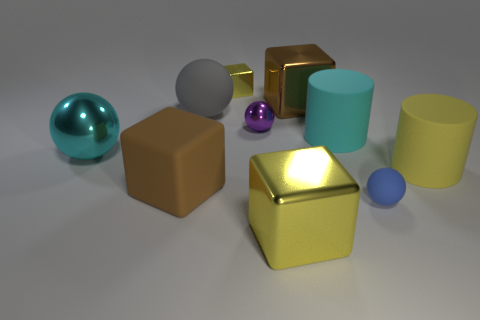Subtract all shiny blocks. How many blocks are left? 1 Subtract all red cylinders. How many yellow cubes are left? 2 Subtract all cyan balls. How many balls are left? 3 Subtract all brown spheres. Subtract all purple cylinders. How many spheres are left? 4 Subtract all spheres. How many objects are left? 6 Add 2 purple matte balls. How many purple matte balls exist? 2 Subtract 1 cyan spheres. How many objects are left? 9 Subtract all big cyan spheres. Subtract all small cubes. How many objects are left? 8 Add 7 big gray rubber objects. How many big gray rubber objects are left? 8 